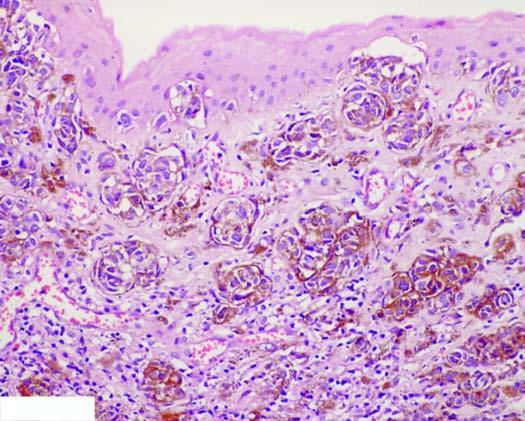do defects in any of the six contain coarse, granular, brown-black melanin pigment?
Answer the question using a single word or phrase. No 